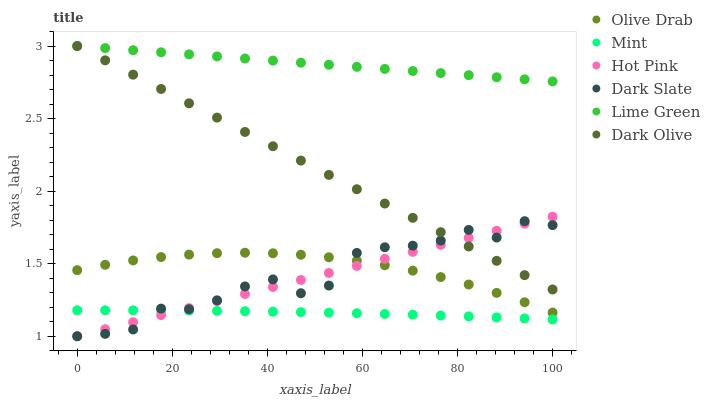Does Mint have the minimum area under the curve?
Answer yes or no. Yes. Does Lime Green have the maximum area under the curve?
Answer yes or no. Yes. Does Dark Olive have the minimum area under the curve?
Answer yes or no. No. Does Dark Olive have the maximum area under the curve?
Answer yes or no. No. Is Hot Pink the smoothest?
Answer yes or no. Yes. Is Dark Slate the roughest?
Answer yes or no. Yes. Is Mint the smoothest?
Answer yes or no. No. Is Mint the roughest?
Answer yes or no. No. Does Hot Pink have the lowest value?
Answer yes or no. Yes. Does Mint have the lowest value?
Answer yes or no. No. Does Lime Green have the highest value?
Answer yes or no. Yes. Does Mint have the highest value?
Answer yes or no. No. Is Mint less than Olive Drab?
Answer yes or no. Yes. Is Lime Green greater than Olive Drab?
Answer yes or no. Yes. Does Dark Slate intersect Mint?
Answer yes or no. Yes. Is Dark Slate less than Mint?
Answer yes or no. No. Is Dark Slate greater than Mint?
Answer yes or no. No. Does Mint intersect Olive Drab?
Answer yes or no. No. 